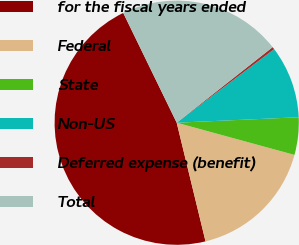Convert chart. <chart><loc_0><loc_0><loc_500><loc_500><pie_chart><fcel>for the fiscal years ended<fcel>Federal<fcel>State<fcel>Non-US<fcel>Deferred expense (benefit)<fcel>Total<nl><fcel>46.58%<fcel>16.96%<fcel>4.96%<fcel>9.58%<fcel>0.33%<fcel>21.59%<nl></chart> 